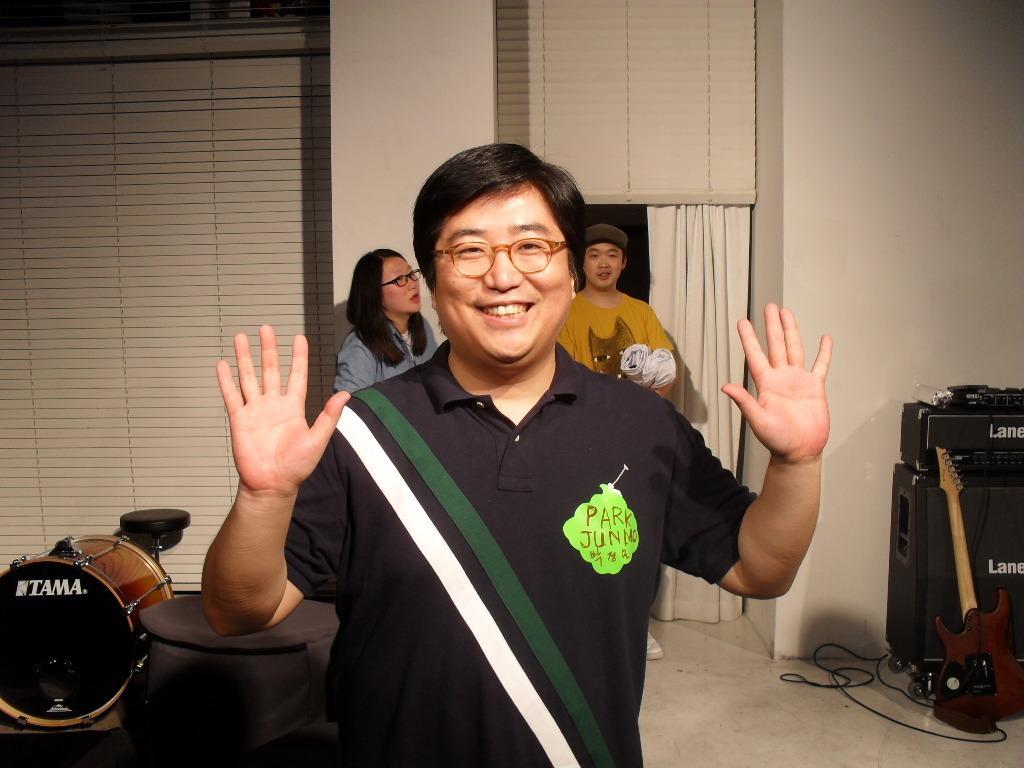Describe this image in one or two sentences. In this image there is a person standing wearing glasses and T-shirt giving pose for a photograph, in the background there are musical instruments and two people standing and there are wall for that wall there is a door, curtain. 